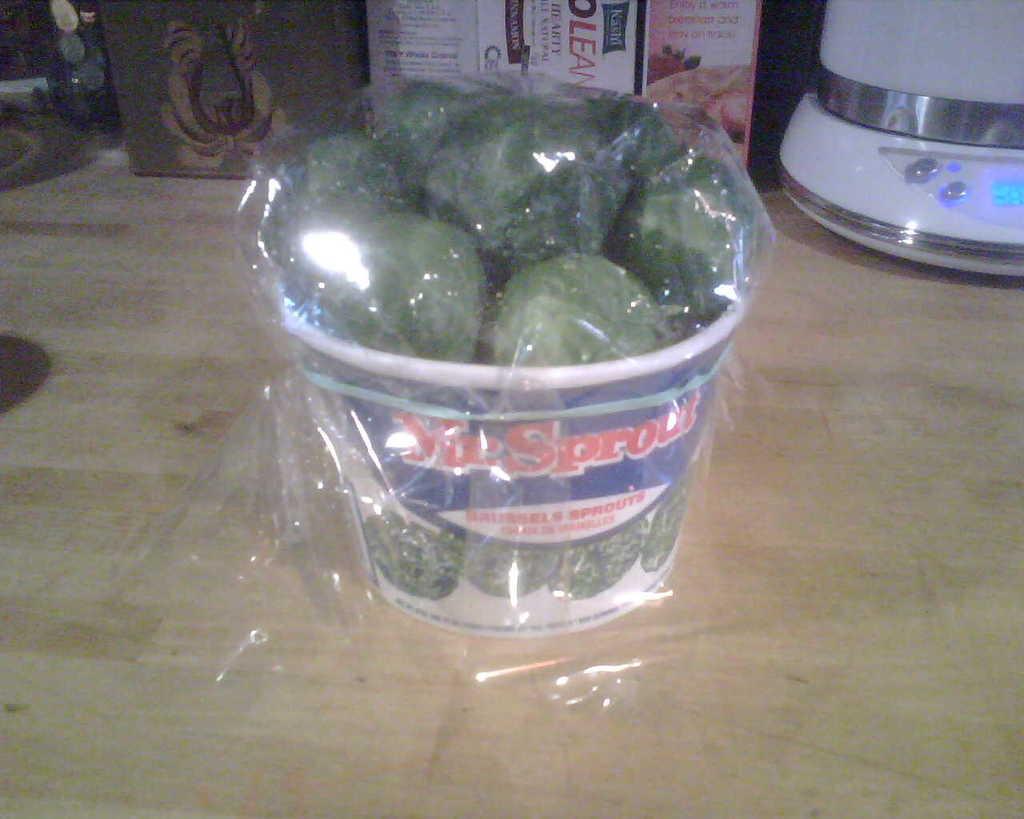What type of sporuts are these?
Your response must be concise. Brussel. 